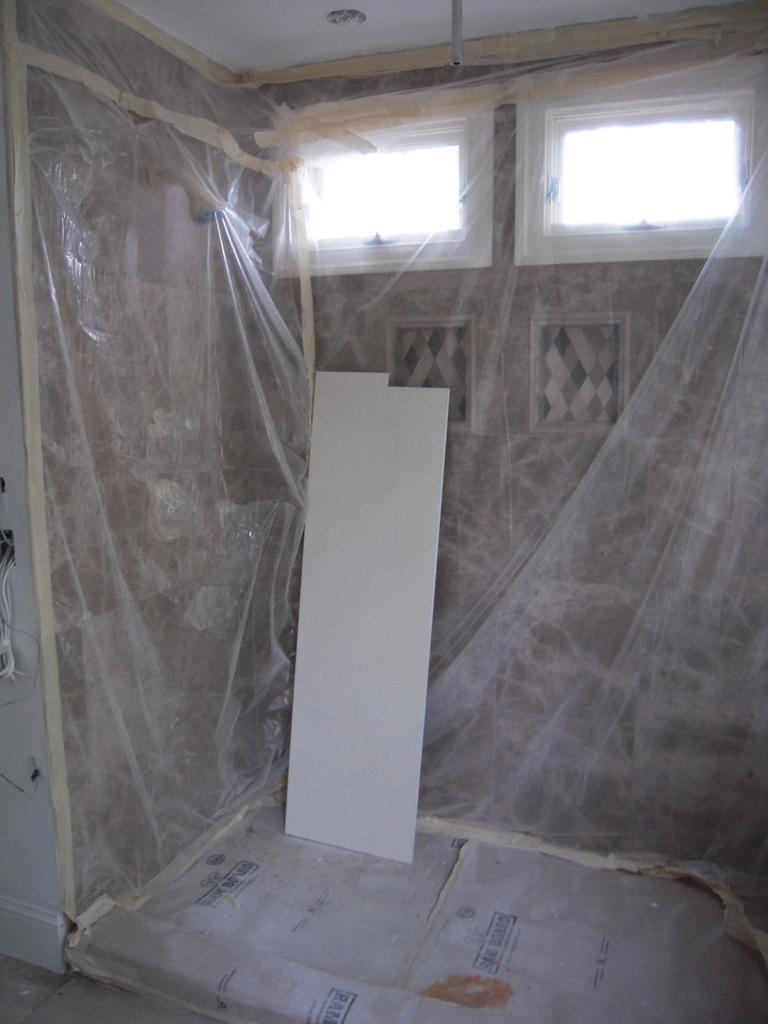Describe this image in one or two sentences. In this room we can see walls are covered with a cover and there is a board on the floor leaning on a wall and there are two windows and on the left side wall we can see cables. On the roof top there is a pipe. 